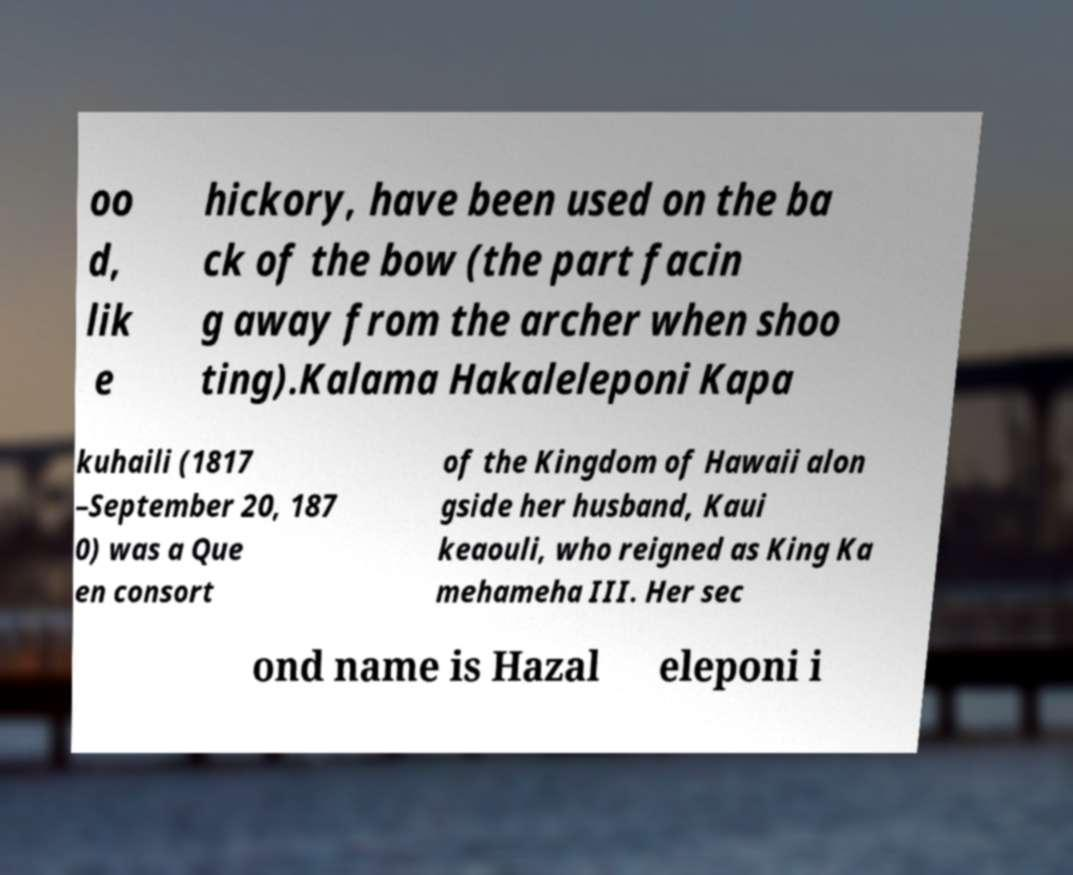I need the written content from this picture converted into text. Can you do that? oo d, lik e hickory, have been used on the ba ck of the bow (the part facin g away from the archer when shoo ting).Kalama Hakaleleponi Kapa kuhaili (1817 –September 20, 187 0) was a Que en consort of the Kingdom of Hawaii alon gside her husband, Kaui keaouli, who reigned as King Ka mehameha III. Her sec ond name is Hazal eleponi i 